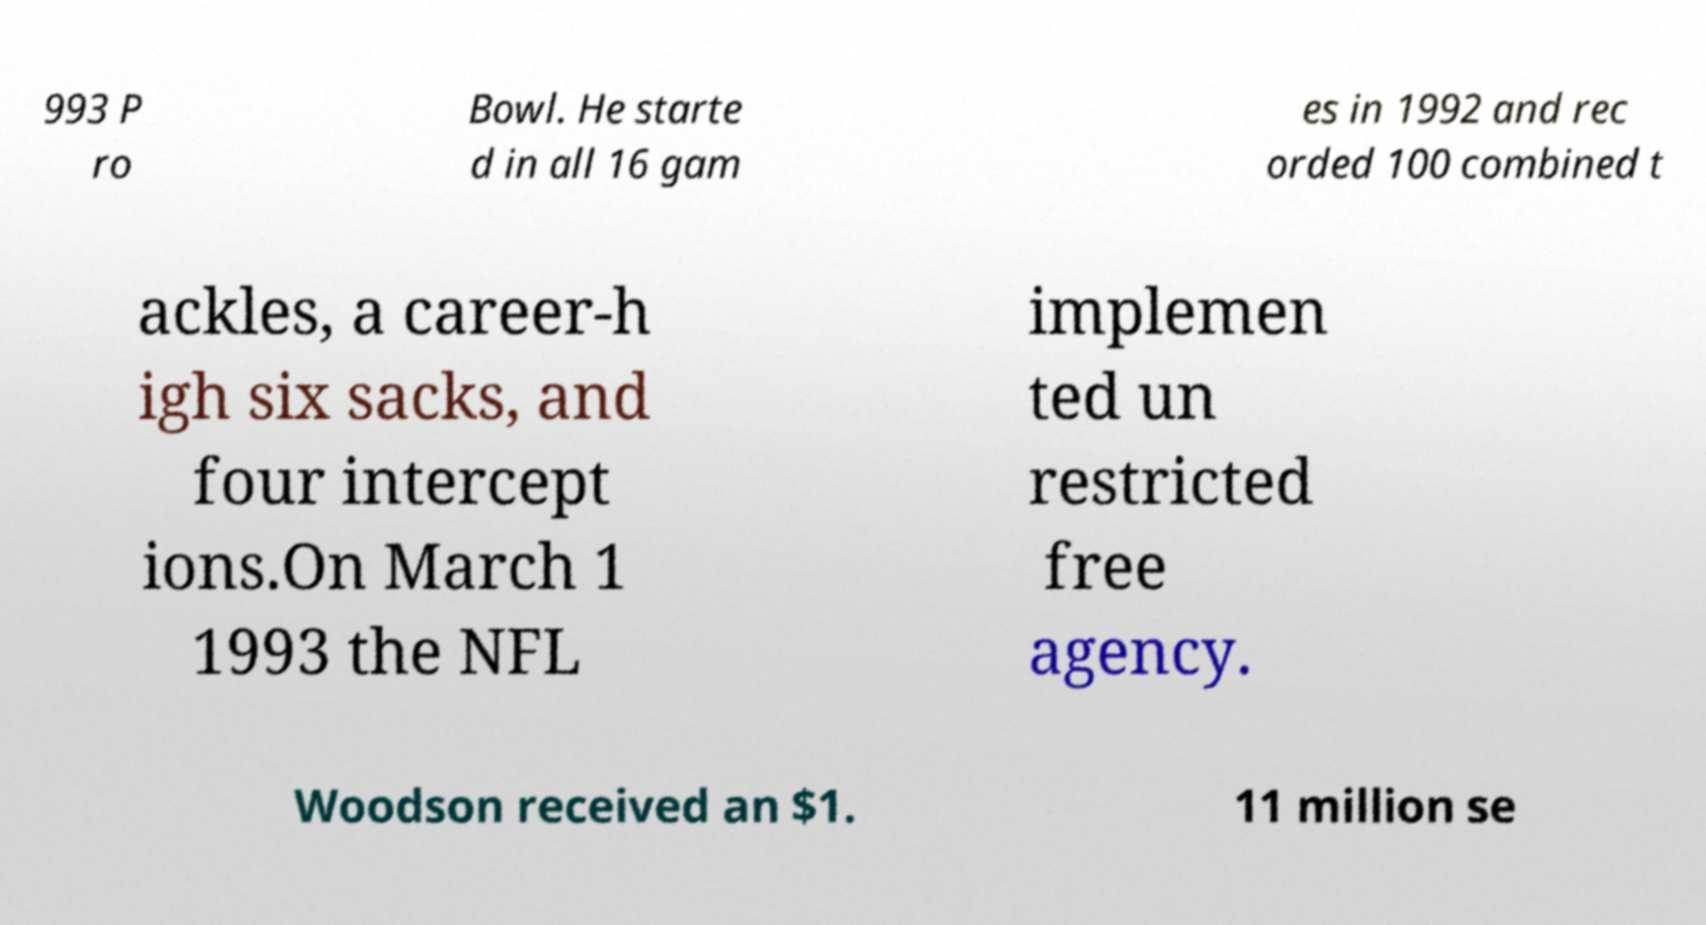Could you extract and type out the text from this image? 993 P ro Bowl. He starte d in all 16 gam es in 1992 and rec orded 100 combined t ackles, a career-h igh six sacks, and four intercept ions.On March 1 1993 the NFL implemen ted un restricted free agency. Woodson received an $1. 11 million se 